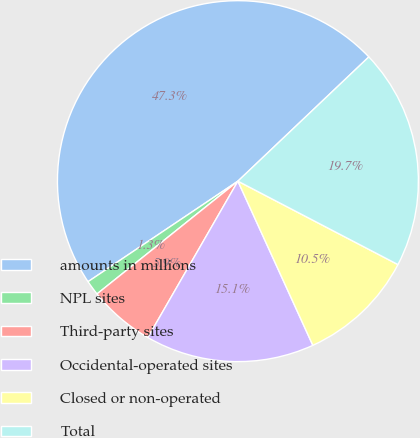Convert chart to OTSL. <chart><loc_0><loc_0><loc_500><loc_500><pie_chart><fcel>amounts in millions<fcel>NPL sites<fcel>Third-party sites<fcel>Occidental-operated sites<fcel>Closed or non-operated<fcel>Total<nl><fcel>47.32%<fcel>1.34%<fcel>5.94%<fcel>15.13%<fcel>10.54%<fcel>19.73%<nl></chart> 